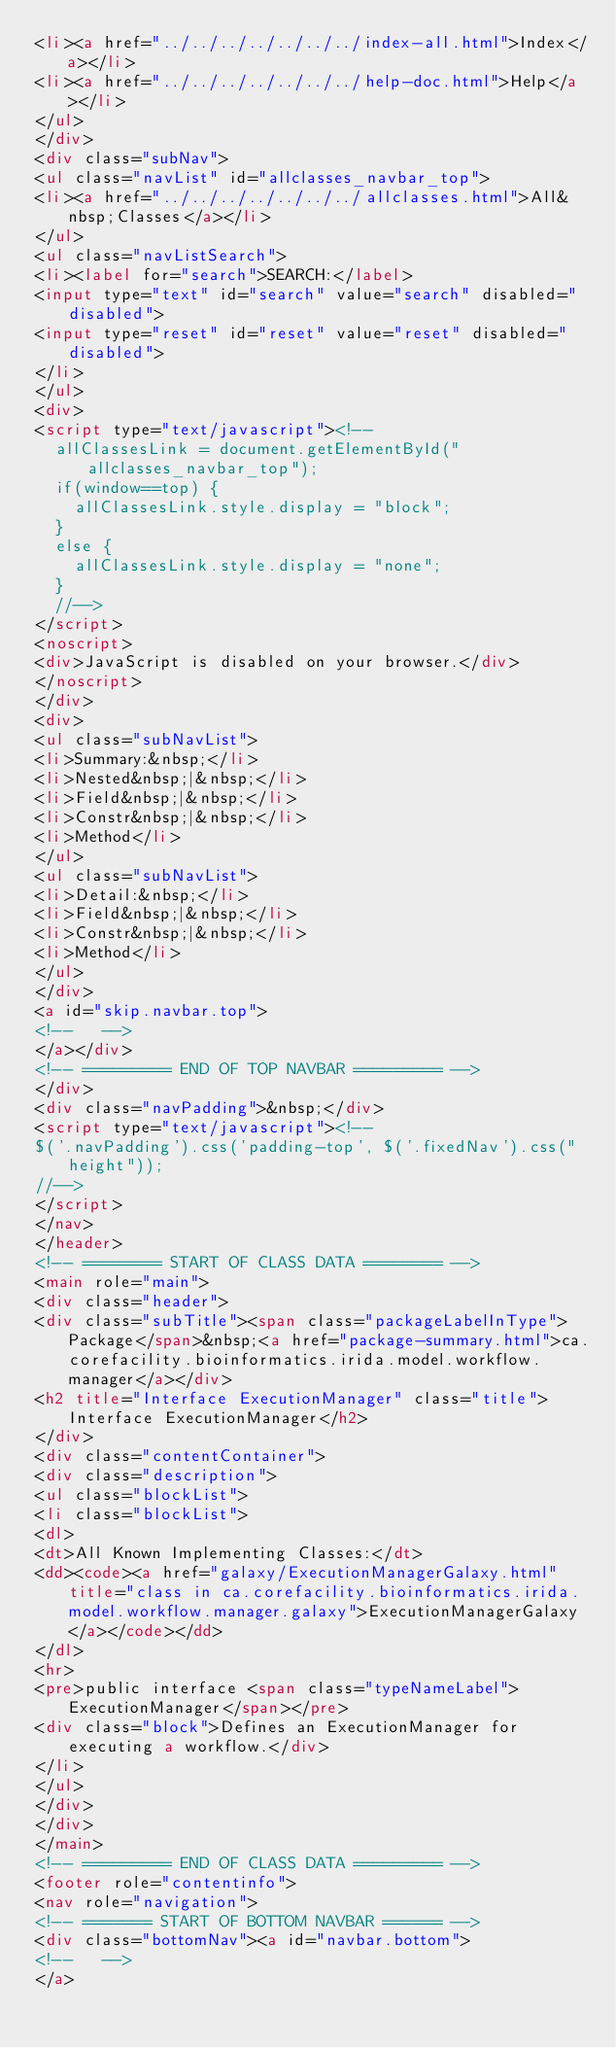<code> <loc_0><loc_0><loc_500><loc_500><_HTML_><li><a href="../../../../../../../index-all.html">Index</a></li>
<li><a href="../../../../../../../help-doc.html">Help</a></li>
</ul>
</div>
<div class="subNav">
<ul class="navList" id="allclasses_navbar_top">
<li><a href="../../../../../../../allclasses.html">All&nbsp;Classes</a></li>
</ul>
<ul class="navListSearch">
<li><label for="search">SEARCH:</label>
<input type="text" id="search" value="search" disabled="disabled">
<input type="reset" id="reset" value="reset" disabled="disabled">
</li>
</ul>
<div>
<script type="text/javascript"><!--
  allClassesLink = document.getElementById("allclasses_navbar_top");
  if(window==top) {
    allClassesLink.style.display = "block";
  }
  else {
    allClassesLink.style.display = "none";
  }
  //-->
</script>
<noscript>
<div>JavaScript is disabled on your browser.</div>
</noscript>
</div>
<div>
<ul class="subNavList">
<li>Summary:&nbsp;</li>
<li>Nested&nbsp;|&nbsp;</li>
<li>Field&nbsp;|&nbsp;</li>
<li>Constr&nbsp;|&nbsp;</li>
<li>Method</li>
</ul>
<ul class="subNavList">
<li>Detail:&nbsp;</li>
<li>Field&nbsp;|&nbsp;</li>
<li>Constr&nbsp;|&nbsp;</li>
<li>Method</li>
</ul>
</div>
<a id="skip.navbar.top">
<!--   -->
</a></div>
<!-- ========= END OF TOP NAVBAR ========= -->
</div>
<div class="navPadding">&nbsp;</div>
<script type="text/javascript"><!--
$('.navPadding').css('padding-top', $('.fixedNav').css("height"));
//-->
</script>
</nav>
</header>
<!-- ======== START OF CLASS DATA ======== -->
<main role="main">
<div class="header">
<div class="subTitle"><span class="packageLabelInType">Package</span>&nbsp;<a href="package-summary.html">ca.corefacility.bioinformatics.irida.model.workflow.manager</a></div>
<h2 title="Interface ExecutionManager" class="title">Interface ExecutionManager</h2>
</div>
<div class="contentContainer">
<div class="description">
<ul class="blockList">
<li class="blockList">
<dl>
<dt>All Known Implementing Classes:</dt>
<dd><code><a href="galaxy/ExecutionManagerGalaxy.html" title="class in ca.corefacility.bioinformatics.irida.model.workflow.manager.galaxy">ExecutionManagerGalaxy</a></code></dd>
</dl>
<hr>
<pre>public interface <span class="typeNameLabel">ExecutionManager</span></pre>
<div class="block">Defines an ExecutionManager for executing a workflow.</div>
</li>
</ul>
</div>
</div>
</main>
<!-- ========= END OF CLASS DATA ========= -->
<footer role="contentinfo">
<nav role="navigation">
<!-- ======= START OF BOTTOM NAVBAR ====== -->
<div class="bottomNav"><a id="navbar.bottom">
<!--   -->
</a></code> 